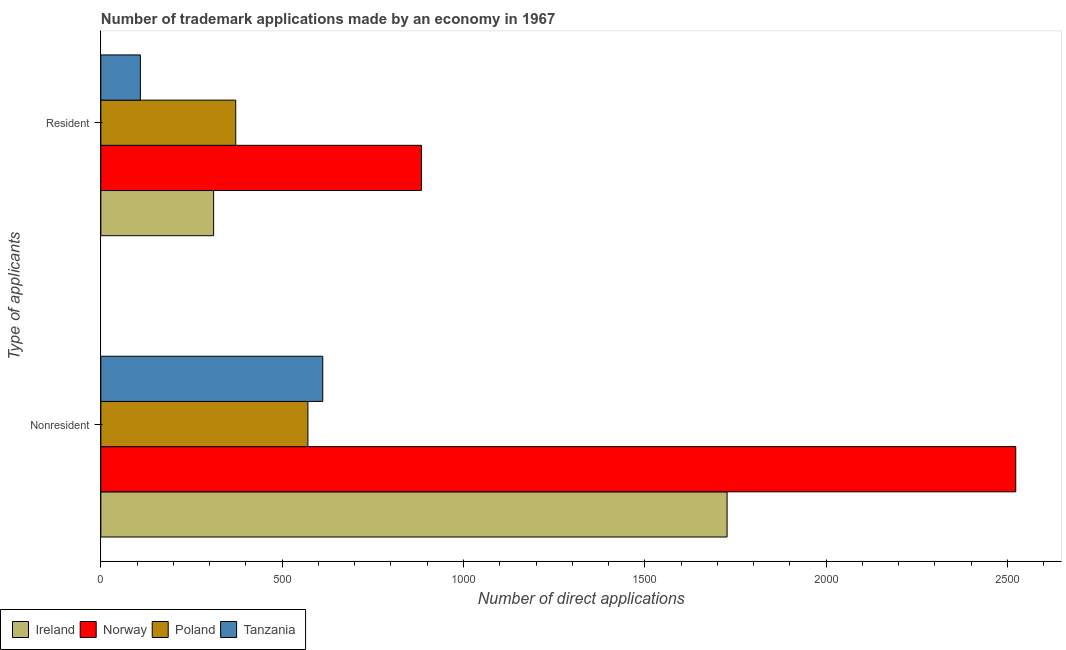How many different coloured bars are there?
Provide a short and direct response. 4. How many groups of bars are there?
Your answer should be very brief. 2. Are the number of bars per tick equal to the number of legend labels?
Make the answer very short. Yes. Are the number of bars on each tick of the Y-axis equal?
Give a very brief answer. Yes. How many bars are there on the 1st tick from the top?
Offer a very short reply. 4. How many bars are there on the 2nd tick from the bottom?
Keep it short and to the point. 4. What is the label of the 1st group of bars from the top?
Your answer should be very brief. Resident. What is the number of trademark applications made by non residents in Tanzania?
Make the answer very short. 612. Across all countries, what is the maximum number of trademark applications made by non residents?
Make the answer very short. 2523. Across all countries, what is the minimum number of trademark applications made by residents?
Your answer should be compact. 109. In which country was the number of trademark applications made by non residents minimum?
Provide a succinct answer. Poland. What is the total number of trademark applications made by residents in the graph?
Offer a very short reply. 1676. What is the difference between the number of trademark applications made by non residents in Poland and that in Ireland?
Ensure brevity in your answer.  -1156. What is the difference between the number of trademark applications made by residents in Norway and the number of trademark applications made by non residents in Poland?
Provide a short and direct response. 313. What is the average number of trademark applications made by non residents per country?
Your answer should be very brief. 1358.25. What is the difference between the number of trademark applications made by residents and number of trademark applications made by non residents in Poland?
Your answer should be very brief. -199. What is the ratio of the number of trademark applications made by residents in Tanzania to that in Ireland?
Provide a short and direct response. 0.35. What does the 4th bar from the top in Resident represents?
Keep it short and to the point. Ireland. What does the 1st bar from the bottom in Resident represents?
Your response must be concise. Ireland. Are all the bars in the graph horizontal?
Offer a terse response. Yes. What is the difference between two consecutive major ticks on the X-axis?
Offer a terse response. 500. Are the values on the major ticks of X-axis written in scientific E-notation?
Provide a short and direct response. No. Does the graph contain any zero values?
Ensure brevity in your answer.  No. How many legend labels are there?
Your answer should be compact. 4. How are the legend labels stacked?
Your answer should be very brief. Horizontal. What is the title of the graph?
Ensure brevity in your answer.  Number of trademark applications made by an economy in 1967. What is the label or title of the X-axis?
Make the answer very short. Number of direct applications. What is the label or title of the Y-axis?
Your answer should be very brief. Type of applicants. What is the Number of direct applications in Ireland in Nonresident?
Offer a very short reply. 1727. What is the Number of direct applications of Norway in Nonresident?
Your answer should be very brief. 2523. What is the Number of direct applications of Poland in Nonresident?
Make the answer very short. 571. What is the Number of direct applications of Tanzania in Nonresident?
Keep it short and to the point. 612. What is the Number of direct applications of Ireland in Resident?
Your answer should be compact. 311. What is the Number of direct applications in Norway in Resident?
Offer a very short reply. 884. What is the Number of direct applications in Poland in Resident?
Your answer should be compact. 372. What is the Number of direct applications of Tanzania in Resident?
Offer a terse response. 109. Across all Type of applicants, what is the maximum Number of direct applications in Ireland?
Provide a short and direct response. 1727. Across all Type of applicants, what is the maximum Number of direct applications of Norway?
Your response must be concise. 2523. Across all Type of applicants, what is the maximum Number of direct applications of Poland?
Offer a terse response. 571. Across all Type of applicants, what is the maximum Number of direct applications of Tanzania?
Offer a very short reply. 612. Across all Type of applicants, what is the minimum Number of direct applications of Ireland?
Keep it short and to the point. 311. Across all Type of applicants, what is the minimum Number of direct applications in Norway?
Offer a terse response. 884. Across all Type of applicants, what is the minimum Number of direct applications of Poland?
Offer a very short reply. 372. Across all Type of applicants, what is the minimum Number of direct applications of Tanzania?
Your answer should be compact. 109. What is the total Number of direct applications of Ireland in the graph?
Ensure brevity in your answer.  2038. What is the total Number of direct applications in Norway in the graph?
Ensure brevity in your answer.  3407. What is the total Number of direct applications of Poland in the graph?
Your response must be concise. 943. What is the total Number of direct applications of Tanzania in the graph?
Provide a short and direct response. 721. What is the difference between the Number of direct applications in Ireland in Nonresident and that in Resident?
Provide a short and direct response. 1416. What is the difference between the Number of direct applications of Norway in Nonresident and that in Resident?
Your response must be concise. 1639. What is the difference between the Number of direct applications in Poland in Nonresident and that in Resident?
Give a very brief answer. 199. What is the difference between the Number of direct applications of Tanzania in Nonresident and that in Resident?
Give a very brief answer. 503. What is the difference between the Number of direct applications in Ireland in Nonresident and the Number of direct applications in Norway in Resident?
Keep it short and to the point. 843. What is the difference between the Number of direct applications of Ireland in Nonresident and the Number of direct applications of Poland in Resident?
Make the answer very short. 1355. What is the difference between the Number of direct applications in Ireland in Nonresident and the Number of direct applications in Tanzania in Resident?
Your answer should be compact. 1618. What is the difference between the Number of direct applications of Norway in Nonresident and the Number of direct applications of Poland in Resident?
Ensure brevity in your answer.  2151. What is the difference between the Number of direct applications in Norway in Nonresident and the Number of direct applications in Tanzania in Resident?
Ensure brevity in your answer.  2414. What is the difference between the Number of direct applications of Poland in Nonresident and the Number of direct applications of Tanzania in Resident?
Ensure brevity in your answer.  462. What is the average Number of direct applications in Ireland per Type of applicants?
Ensure brevity in your answer.  1019. What is the average Number of direct applications in Norway per Type of applicants?
Offer a terse response. 1703.5. What is the average Number of direct applications in Poland per Type of applicants?
Give a very brief answer. 471.5. What is the average Number of direct applications in Tanzania per Type of applicants?
Offer a very short reply. 360.5. What is the difference between the Number of direct applications of Ireland and Number of direct applications of Norway in Nonresident?
Make the answer very short. -796. What is the difference between the Number of direct applications of Ireland and Number of direct applications of Poland in Nonresident?
Ensure brevity in your answer.  1156. What is the difference between the Number of direct applications of Ireland and Number of direct applications of Tanzania in Nonresident?
Offer a very short reply. 1115. What is the difference between the Number of direct applications of Norway and Number of direct applications of Poland in Nonresident?
Your response must be concise. 1952. What is the difference between the Number of direct applications of Norway and Number of direct applications of Tanzania in Nonresident?
Give a very brief answer. 1911. What is the difference between the Number of direct applications of Poland and Number of direct applications of Tanzania in Nonresident?
Keep it short and to the point. -41. What is the difference between the Number of direct applications of Ireland and Number of direct applications of Norway in Resident?
Offer a very short reply. -573. What is the difference between the Number of direct applications of Ireland and Number of direct applications of Poland in Resident?
Offer a terse response. -61. What is the difference between the Number of direct applications of Ireland and Number of direct applications of Tanzania in Resident?
Your answer should be very brief. 202. What is the difference between the Number of direct applications of Norway and Number of direct applications of Poland in Resident?
Offer a very short reply. 512. What is the difference between the Number of direct applications of Norway and Number of direct applications of Tanzania in Resident?
Ensure brevity in your answer.  775. What is the difference between the Number of direct applications of Poland and Number of direct applications of Tanzania in Resident?
Your answer should be compact. 263. What is the ratio of the Number of direct applications in Ireland in Nonresident to that in Resident?
Make the answer very short. 5.55. What is the ratio of the Number of direct applications in Norway in Nonresident to that in Resident?
Your answer should be very brief. 2.85. What is the ratio of the Number of direct applications in Poland in Nonresident to that in Resident?
Your answer should be compact. 1.53. What is the ratio of the Number of direct applications in Tanzania in Nonresident to that in Resident?
Provide a succinct answer. 5.61. What is the difference between the highest and the second highest Number of direct applications of Ireland?
Ensure brevity in your answer.  1416. What is the difference between the highest and the second highest Number of direct applications in Norway?
Make the answer very short. 1639. What is the difference between the highest and the second highest Number of direct applications of Poland?
Make the answer very short. 199. What is the difference between the highest and the second highest Number of direct applications of Tanzania?
Offer a very short reply. 503. What is the difference between the highest and the lowest Number of direct applications in Ireland?
Give a very brief answer. 1416. What is the difference between the highest and the lowest Number of direct applications of Norway?
Your answer should be very brief. 1639. What is the difference between the highest and the lowest Number of direct applications of Poland?
Provide a short and direct response. 199. What is the difference between the highest and the lowest Number of direct applications of Tanzania?
Ensure brevity in your answer.  503. 